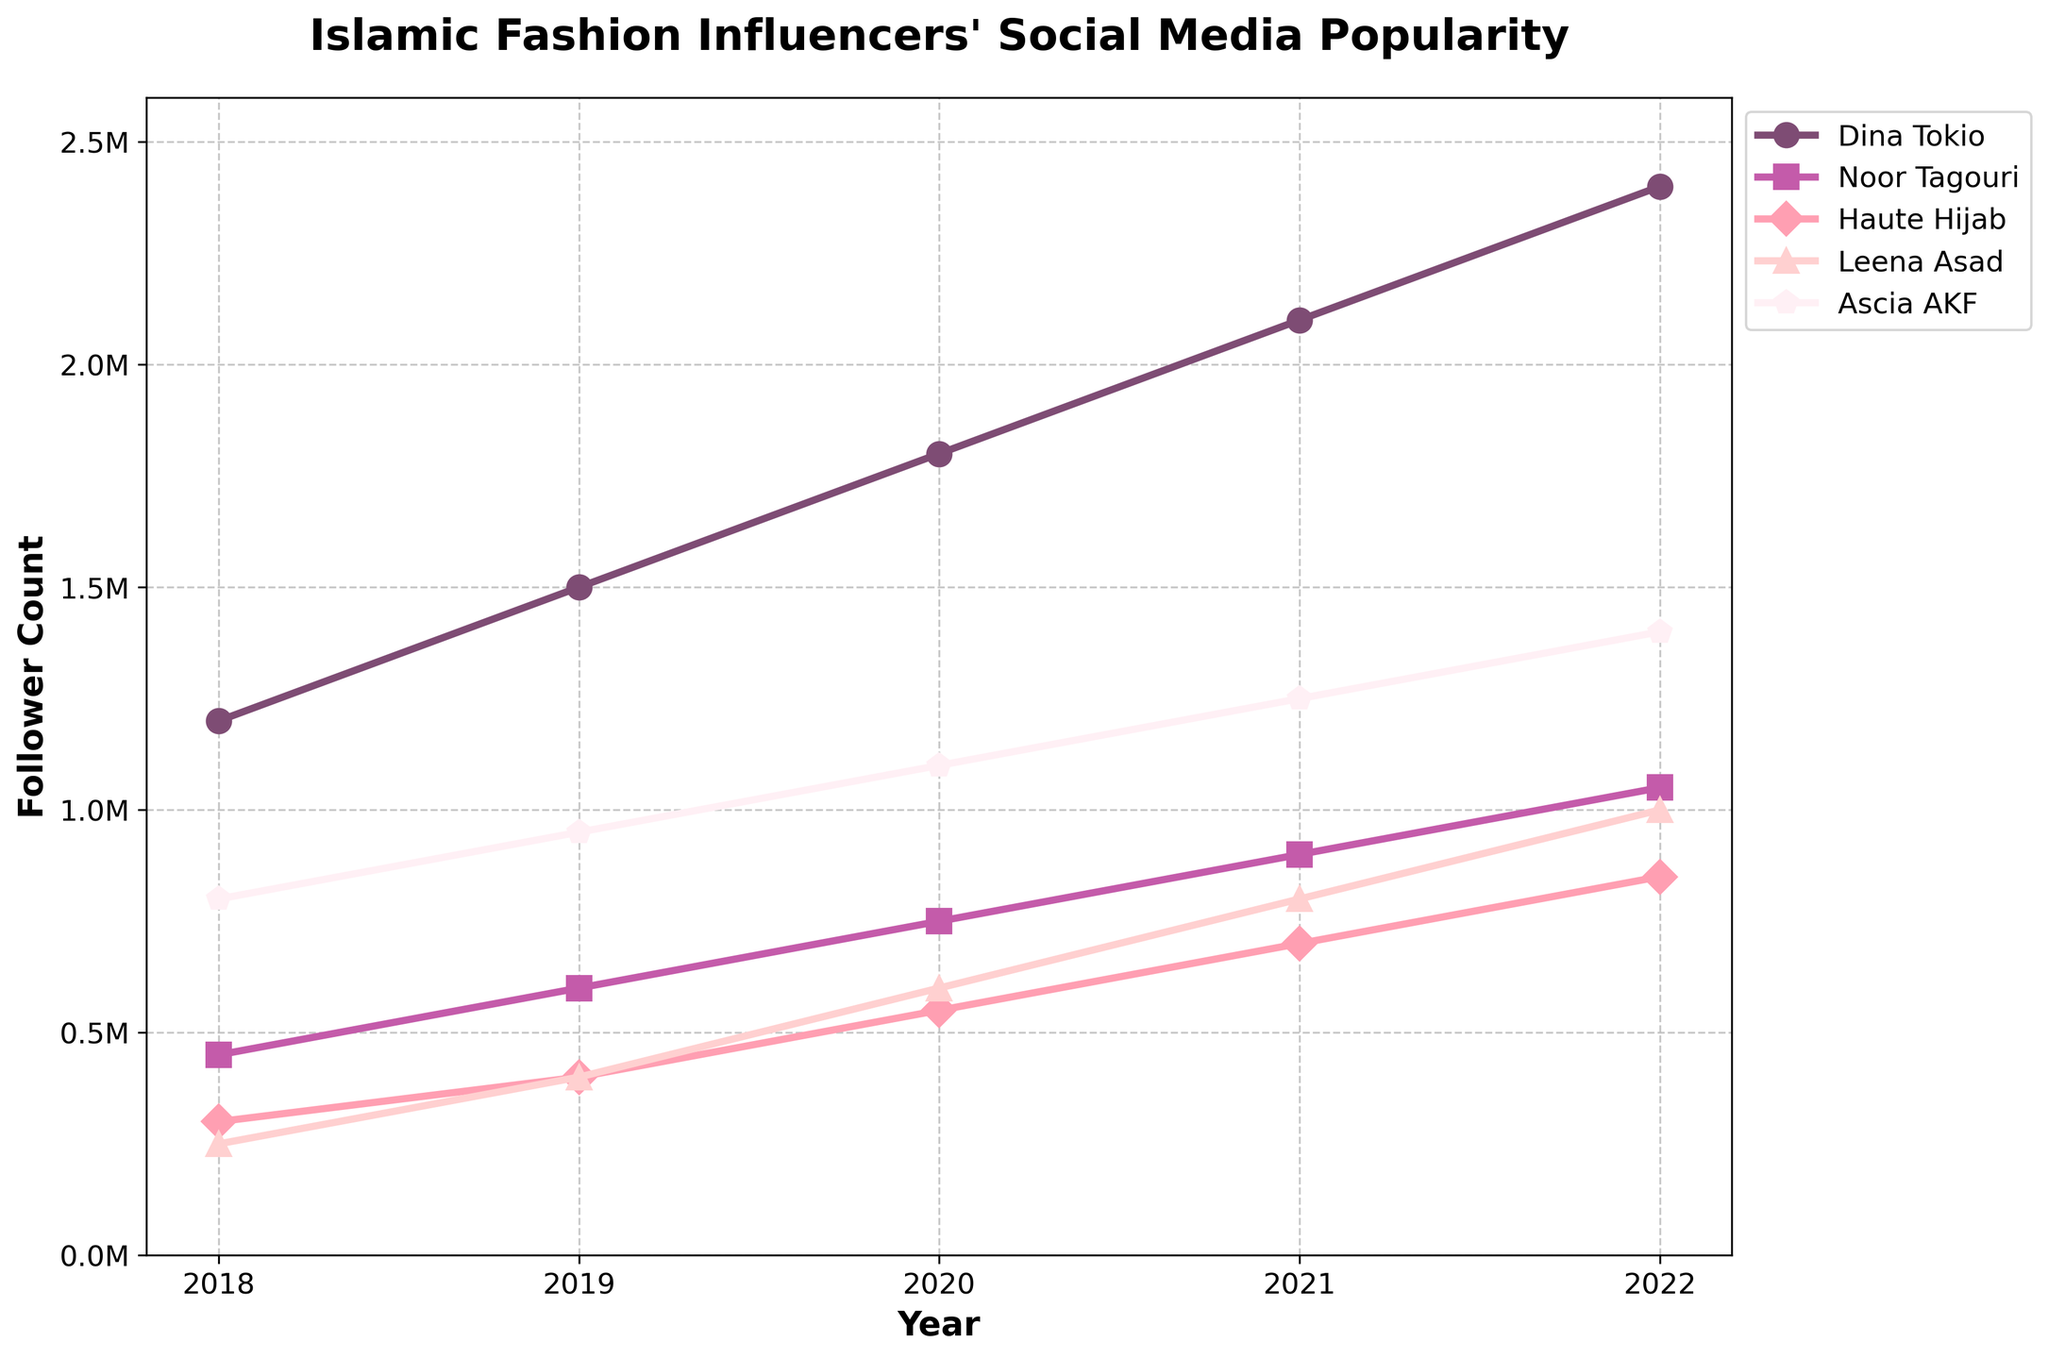What's the largest increase in follower count for any influencer between consecutive years? To find the largest increase, we need to look at the differences in follower counts between each year for each influencer. Dina Tokio's increase from 2018 to 2019 is 300,000, from 2019 to 2020 is 300,000, from 2020 to 2021 is 300,000, and from 2021 to 2022 is 300,000. Noor Tagouri's increases are 150,000, 150,000, 150,000, and 150,000. Haute Hijab's increases are 100,000, 150,000, 150,000, and 150,000. Leena Asad's increases are 150,000, 200,000, 200,000, and 200,000. Ascia AKF's increases are 150,000, 150,000, 150,000, and 150,000. The largest increase is Dina Tokio’s 300,000 increase from 2020 to 2021.
Answer: 300,000 Which influencer had the smallest following in 2018? By examining the follower counts from 2018, Dina Tokio had 1,200,000, Noor Tagouri had 450,000, Haute Hijab had 300,000, Leena Asad had 250,000, and Ascia AKF had 800,000. Leena Asad had the smallest following in 2018.
Answer: Leena Asad Who had more followers in 2020, Noor Tagouri or Haute Hijab? In 2020, Noor Tagouri had 750,000 followers, and Haute Hijab had 550,000 followers. Therefore, Noor Tagouri had more followers.
Answer: Noor Tagouri Which influencer showed the most consistent growth each year? Consistent growth means the follower count increases by a similar value each year. Dina Tokio's increases are 300,000 each year, which is very consistent. Other influencers have varying increases. Thus, Dina Tokio showed the most consistent growth.
Answer: Dina Tokio What is the average follower count of Leena Asad over these 5 years? To find the average, sum Leena Asad's followers from 2018 to 2022 and divide by 5. The follower counts are 250,000, 400,000, 600,000, 800,000, and 1,000,000. (250,000 + 400,000 + 600,000 + 800,000 + 1,000,000) / 5 = 3,050,000 / 5 = 610,000.
Answer: 610,000 Which influencer had the highest follower count in 2022? In 2022, the follower counts are Dina Tokio (2,400,000), Noor Tagouri (1,050,000), Haute Hijab (850,000), Leena Asad (1,000,000), and Ascia AKF (1,400,000). Dina Tokio had the highest follower count.
Answer: Dina Tokio How many total followers did all influencers have in 2019? Sum the follower counts in 2019: Dina Tokio (1,500,000), Noor Tagouri (600,000), Haute Hijab (400,000), Leena Asad (400,000), and Ascia AKF (950,000). 1,500,000 + 600,000 + 400,000 + 400,000 + 950,000 = 3,850,000.
Answer: 3,850,000 Between 2018 and 2022, which influencer had the highest percentage growth in followers? To find the highest percentage growth, calculate the growth for each influencer: Dina Tokio: ((2,400,000 - 1,200,000) / 1,200,000) * 100 = 100%, Noor Tagouri: ((1,050,000 - 450,000) / 450,000) * 100 = 133.33%, Haute Hijab: ((850,000 - 300,000) / 300,000) * 100 = 183.33%, Leena Asad: ((1,000,000 - 250,000) / 250,000) * 100 = 300%, Ascia AKF: ((1,400,000 - 800,000) / 800,000) * 100 = 75%. Leena Asad had the highest percentage growth.
Answer: Leena Asad Did any influencer consistently have the second highest follower count between 2018 and 2022? Second highest means having the second largest count each year. Checking each year, Noor Tagouri was not consistently second, Haute Hijab was not, Leena Asad was not, and Ascia AKF was not. No influencer consistently had the second highest follower count.
Answer: No 